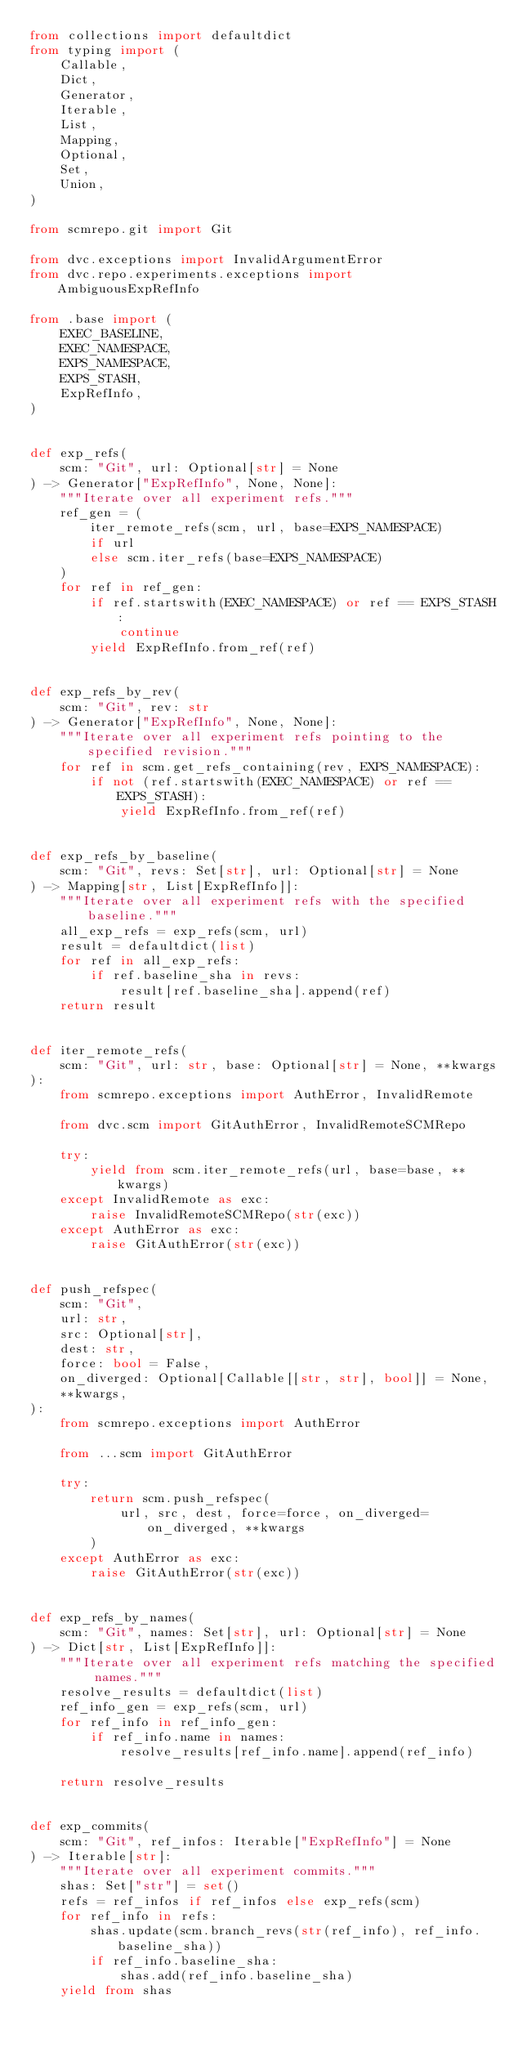<code> <loc_0><loc_0><loc_500><loc_500><_Python_>from collections import defaultdict
from typing import (
    Callable,
    Dict,
    Generator,
    Iterable,
    List,
    Mapping,
    Optional,
    Set,
    Union,
)

from scmrepo.git import Git

from dvc.exceptions import InvalidArgumentError
from dvc.repo.experiments.exceptions import AmbiguousExpRefInfo

from .base import (
    EXEC_BASELINE,
    EXEC_NAMESPACE,
    EXPS_NAMESPACE,
    EXPS_STASH,
    ExpRefInfo,
)


def exp_refs(
    scm: "Git", url: Optional[str] = None
) -> Generator["ExpRefInfo", None, None]:
    """Iterate over all experiment refs."""
    ref_gen = (
        iter_remote_refs(scm, url, base=EXPS_NAMESPACE)
        if url
        else scm.iter_refs(base=EXPS_NAMESPACE)
    )
    for ref in ref_gen:
        if ref.startswith(EXEC_NAMESPACE) or ref == EXPS_STASH:
            continue
        yield ExpRefInfo.from_ref(ref)


def exp_refs_by_rev(
    scm: "Git", rev: str
) -> Generator["ExpRefInfo", None, None]:
    """Iterate over all experiment refs pointing to the specified revision."""
    for ref in scm.get_refs_containing(rev, EXPS_NAMESPACE):
        if not (ref.startswith(EXEC_NAMESPACE) or ref == EXPS_STASH):
            yield ExpRefInfo.from_ref(ref)


def exp_refs_by_baseline(
    scm: "Git", revs: Set[str], url: Optional[str] = None
) -> Mapping[str, List[ExpRefInfo]]:
    """Iterate over all experiment refs with the specified baseline."""
    all_exp_refs = exp_refs(scm, url)
    result = defaultdict(list)
    for ref in all_exp_refs:
        if ref.baseline_sha in revs:
            result[ref.baseline_sha].append(ref)
    return result


def iter_remote_refs(
    scm: "Git", url: str, base: Optional[str] = None, **kwargs
):
    from scmrepo.exceptions import AuthError, InvalidRemote

    from dvc.scm import GitAuthError, InvalidRemoteSCMRepo

    try:
        yield from scm.iter_remote_refs(url, base=base, **kwargs)
    except InvalidRemote as exc:
        raise InvalidRemoteSCMRepo(str(exc))
    except AuthError as exc:
        raise GitAuthError(str(exc))


def push_refspec(
    scm: "Git",
    url: str,
    src: Optional[str],
    dest: str,
    force: bool = False,
    on_diverged: Optional[Callable[[str, str], bool]] = None,
    **kwargs,
):
    from scmrepo.exceptions import AuthError

    from ...scm import GitAuthError

    try:
        return scm.push_refspec(
            url, src, dest, force=force, on_diverged=on_diverged, **kwargs
        )
    except AuthError as exc:
        raise GitAuthError(str(exc))


def exp_refs_by_names(
    scm: "Git", names: Set[str], url: Optional[str] = None
) -> Dict[str, List[ExpRefInfo]]:
    """Iterate over all experiment refs matching the specified names."""
    resolve_results = defaultdict(list)
    ref_info_gen = exp_refs(scm, url)
    for ref_info in ref_info_gen:
        if ref_info.name in names:
            resolve_results[ref_info.name].append(ref_info)

    return resolve_results


def exp_commits(
    scm: "Git", ref_infos: Iterable["ExpRefInfo"] = None
) -> Iterable[str]:
    """Iterate over all experiment commits."""
    shas: Set["str"] = set()
    refs = ref_infos if ref_infos else exp_refs(scm)
    for ref_info in refs:
        shas.update(scm.branch_revs(str(ref_info), ref_info.baseline_sha))
        if ref_info.baseline_sha:
            shas.add(ref_info.baseline_sha)
    yield from shas

</code> 